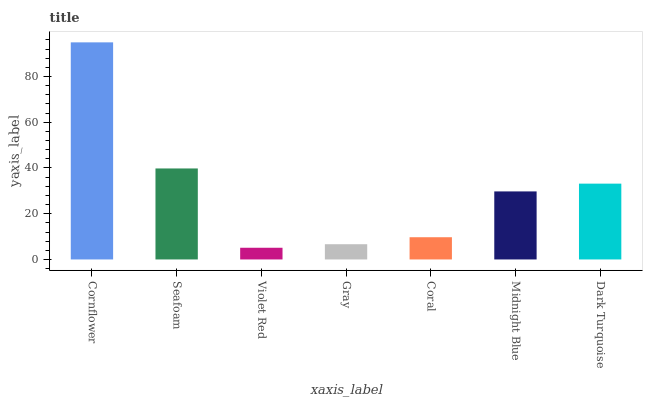Is Violet Red the minimum?
Answer yes or no. Yes. Is Cornflower the maximum?
Answer yes or no. Yes. Is Seafoam the minimum?
Answer yes or no. No. Is Seafoam the maximum?
Answer yes or no. No. Is Cornflower greater than Seafoam?
Answer yes or no. Yes. Is Seafoam less than Cornflower?
Answer yes or no. Yes. Is Seafoam greater than Cornflower?
Answer yes or no. No. Is Cornflower less than Seafoam?
Answer yes or no. No. Is Midnight Blue the high median?
Answer yes or no. Yes. Is Midnight Blue the low median?
Answer yes or no. Yes. Is Gray the high median?
Answer yes or no. No. Is Gray the low median?
Answer yes or no. No. 